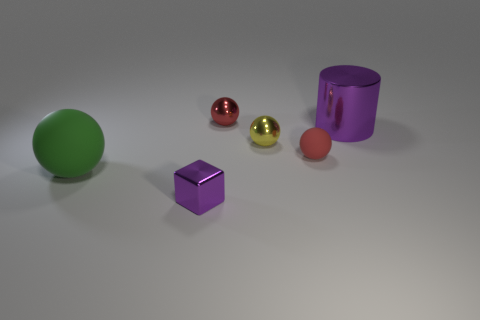What number of red spheres are there?
Your response must be concise. 2. Do the red ball in front of the large purple thing and the large object in front of the tiny yellow thing have the same material?
Your answer should be very brief. Yes. There is a purple object that is the same material as the small purple block; what is its size?
Make the answer very short. Large. There is a purple thing in front of the cylinder; what shape is it?
Provide a succinct answer. Cube. There is a cylinder behind the large ball; is its color the same as the ball that is behind the yellow shiny thing?
Provide a short and direct response. No. There is a metal sphere that is the same color as the small rubber thing; what is its size?
Offer a terse response. Small. Is there a big purple metallic block?
Provide a succinct answer. No. There is a large thing behind the rubber sphere behind the matte sphere that is to the left of the metal block; what shape is it?
Keep it short and to the point. Cylinder. There is a yellow metallic object; how many rubber spheres are right of it?
Your answer should be very brief. 1. Does the big object that is on the left side of the tiny purple metallic object have the same material as the yellow object?
Keep it short and to the point. No. 